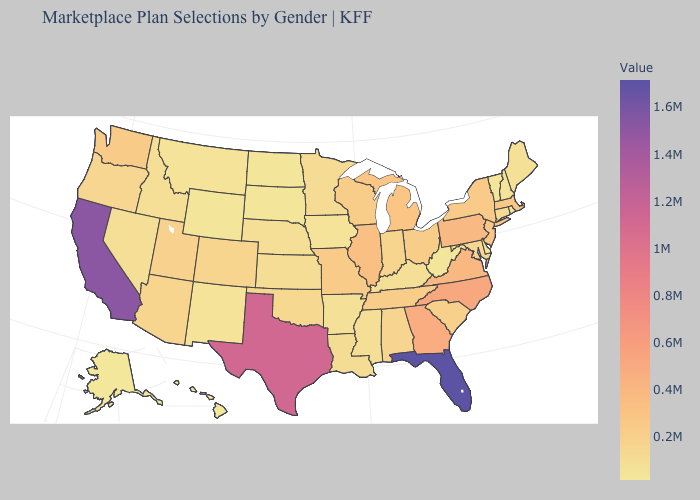Which states have the lowest value in the Northeast?
Short answer required. Vermont. Does Alabama have a lower value than North Carolina?
Short answer required. Yes. Does Missouri have a higher value than Delaware?
Be succinct. Yes. Which states have the lowest value in the USA?
Concise answer only. Alaska. 